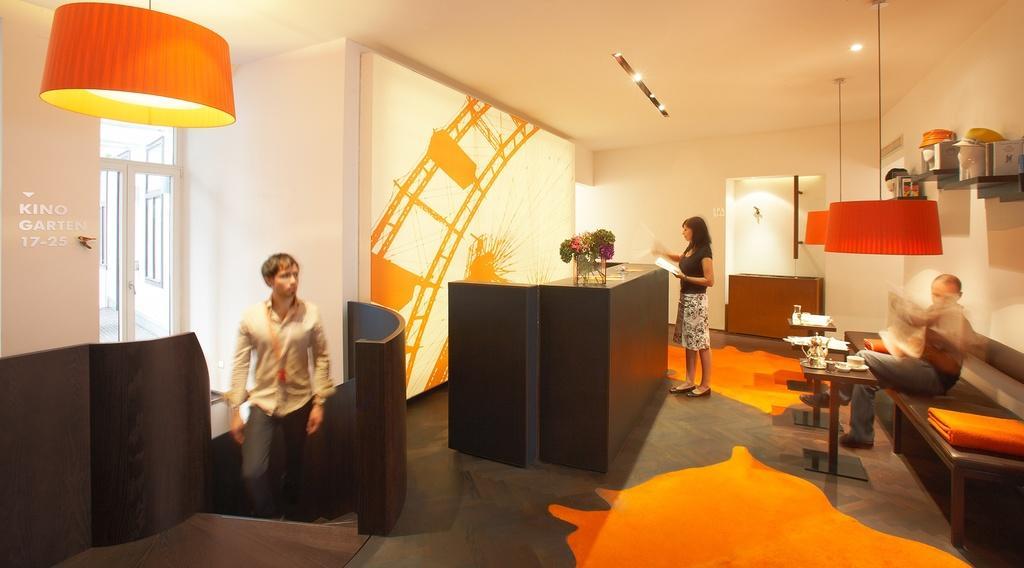How would you summarize this image in a sentence or two? This person standing and holding paper and this person sitting on the bench and this person walking. We can see wall,light,floor,table,on the table we can see kettle,cup. 